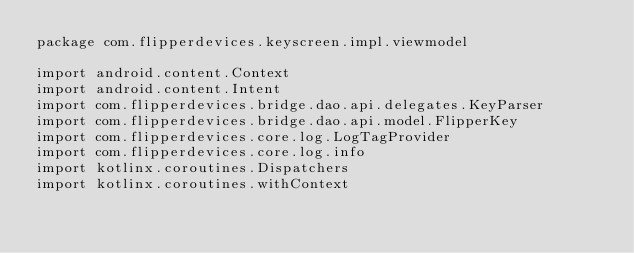<code> <loc_0><loc_0><loc_500><loc_500><_Kotlin_>package com.flipperdevices.keyscreen.impl.viewmodel

import android.content.Context
import android.content.Intent
import com.flipperdevices.bridge.dao.api.delegates.KeyParser
import com.flipperdevices.bridge.dao.api.model.FlipperKey
import com.flipperdevices.core.log.LogTagProvider
import com.flipperdevices.core.log.info
import kotlinx.coroutines.Dispatchers
import kotlinx.coroutines.withContext
</code> 